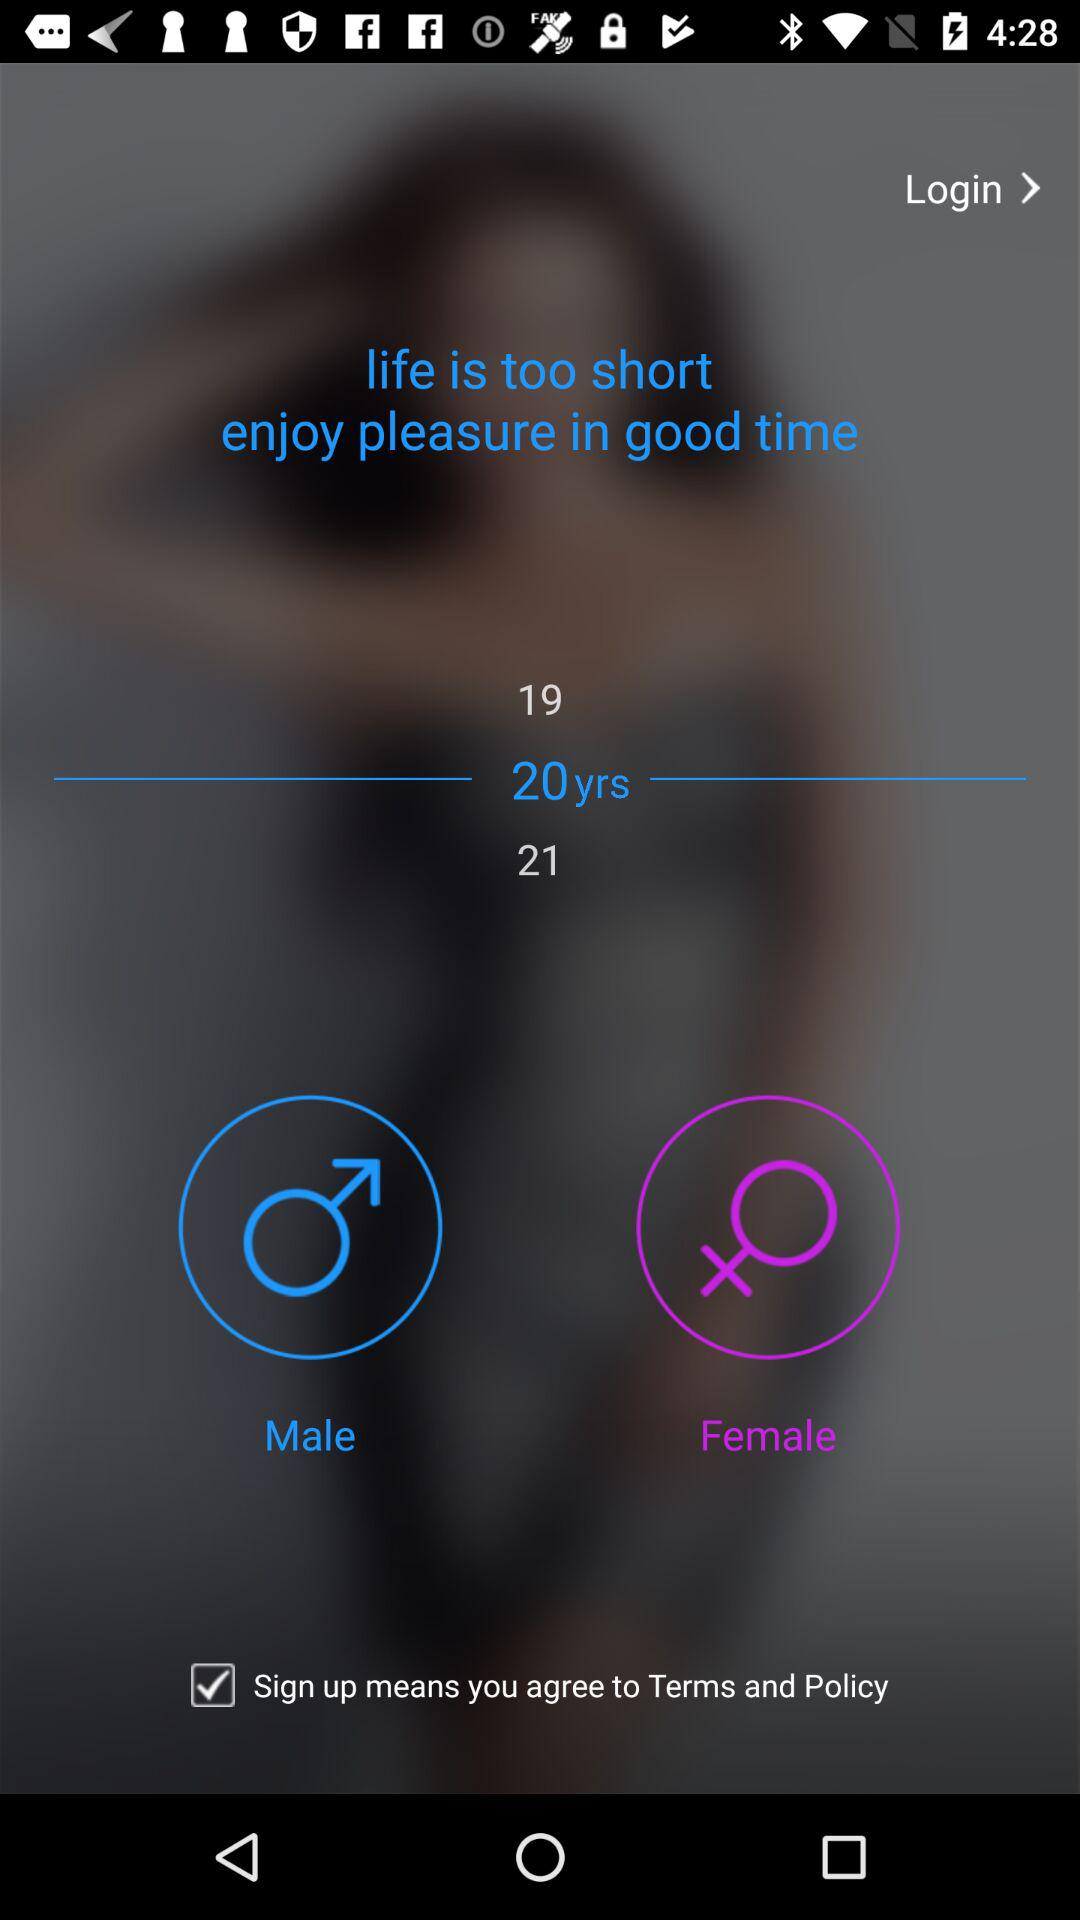Which option has been selected? The option that has been selected is "20yrs". 